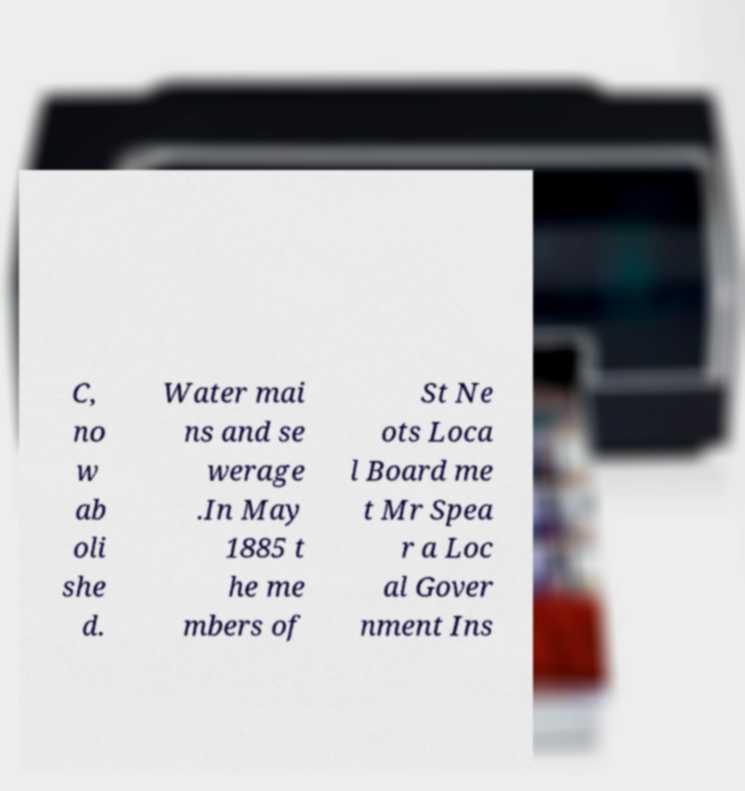What messages or text are displayed in this image? I need them in a readable, typed format. C, no w ab oli she d. Water mai ns and se werage .In May 1885 t he me mbers of St Ne ots Loca l Board me t Mr Spea r a Loc al Gover nment Ins 